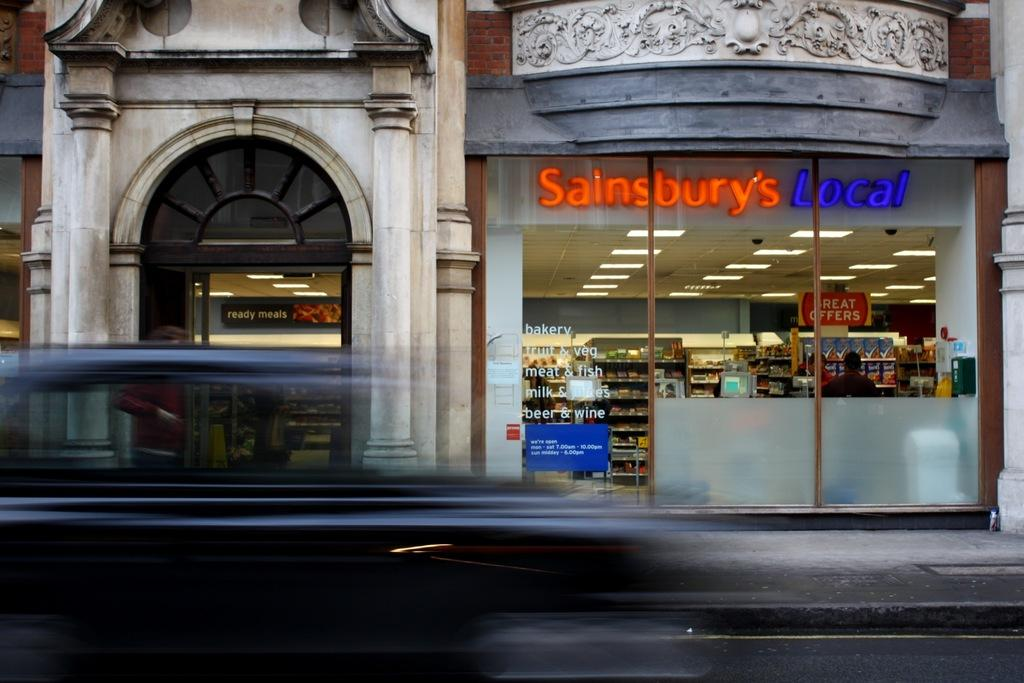What type of structure is visible in the image? There is a building in the image. What architectural feature can be seen in the image? There is a wall and pillars in the image. What signage is present in the image? There are name boards in the image. How can one enter the building? There is a door in the image. Are there any people present in the image? Yes, there are persons in the image. What other items can be seen in the image? There are some objects in the image. What type of treatment is being administered to the bear in the image? There is no bear present in the image, so no treatment can be observed. Can you tell me the age of the grandfather in the image? There is no grandfather present in the image, so his age cannot be determined. 